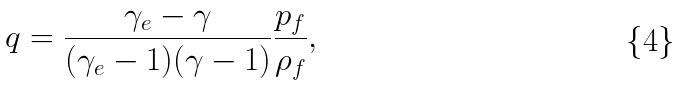<formula> <loc_0><loc_0><loc_500><loc_500>q = \frac { \gamma _ { e } - \gamma } { ( \gamma _ { e } - 1 ) ( \gamma - 1 ) } \frac { p _ { f } } { \rho _ { f } } ,</formula> 